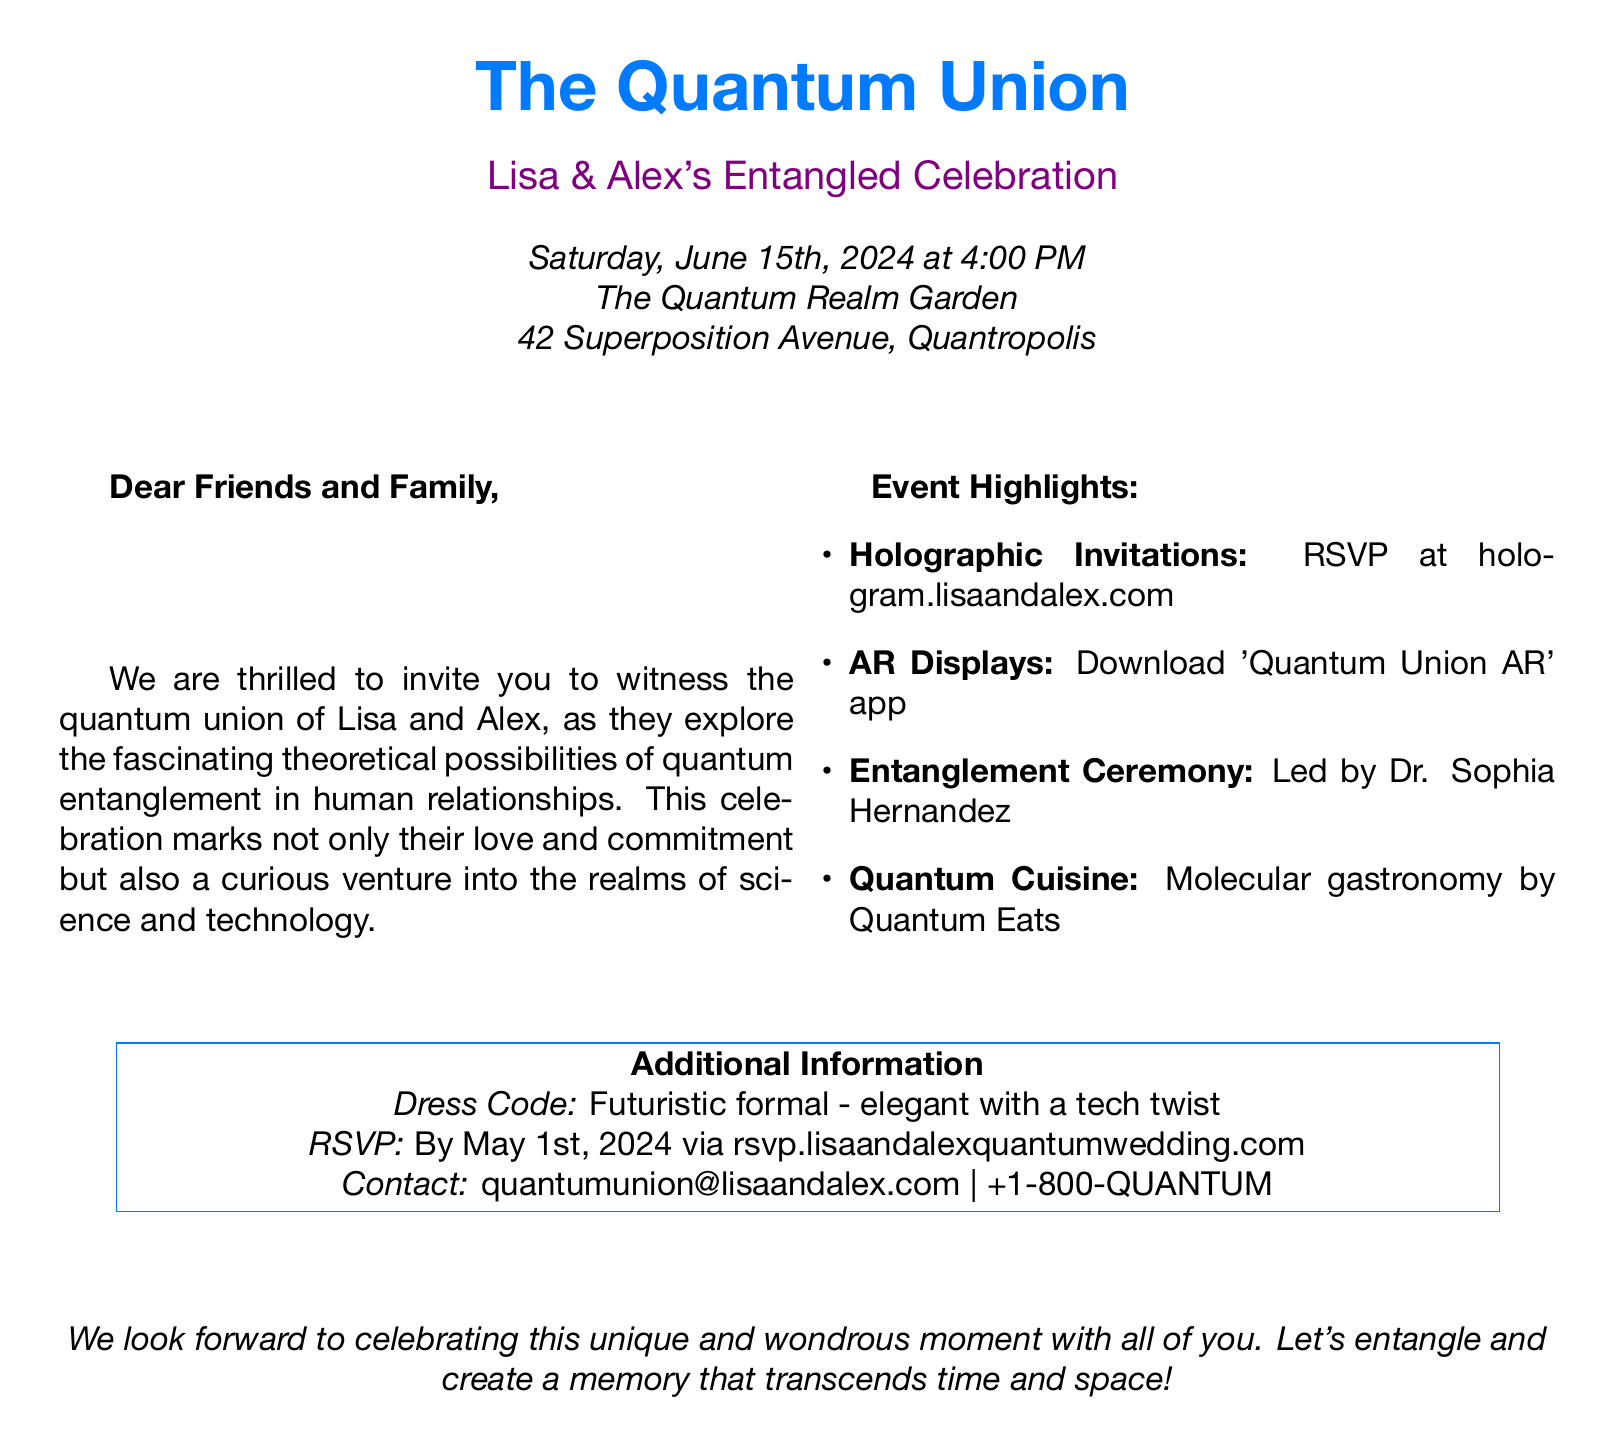What is the date of the wedding? The date of the wedding is explicitly mentioned in the document as Saturday, June 15th, 2024.
Answer: June 15th, 2024 What is the venue of the wedding? The venue is explicitly stated in the document as The Quantum Realm Garden.
Answer: The Quantum Realm Garden Who is officiating the ceremony? The document names Dr. Sophia Hernandez as the person leading the Entanglement Ceremony.
Answer: Dr. Sophia Hernandez What is the dress code for the event? The dress code is mentioned in the additional information section as futuristic formal - elegant with a tech twist.
Answer: Futuristic formal What is the RSVP deadline? The RSVP deadline is clearly stated as May 1st, 2024 in the additional information section.
Answer: May 1st, 2024 What type of culinary experience is provided? The document describes the food as quantum cuisine, specifically mentioning molecular gastronomy by Quantum Eats.
Answer: Molecular gastronomy What technology is mentioned for guest interaction? The document mentions the use of an app called 'Quantum Union AR' for augmented reality displays.
Answer: Quantum Union AR What website is provided for RSVPs? The document provides the RSVP website as rsvp.lisaandalexquantumwedding.com.
Answer: rsvp.lisaandalexquantumwedding.com What is the theme of the wedding? The document refers to the wedding as The Quantum Union, highlighting the theme of quantum entanglement.
Answer: The Quantum Union 